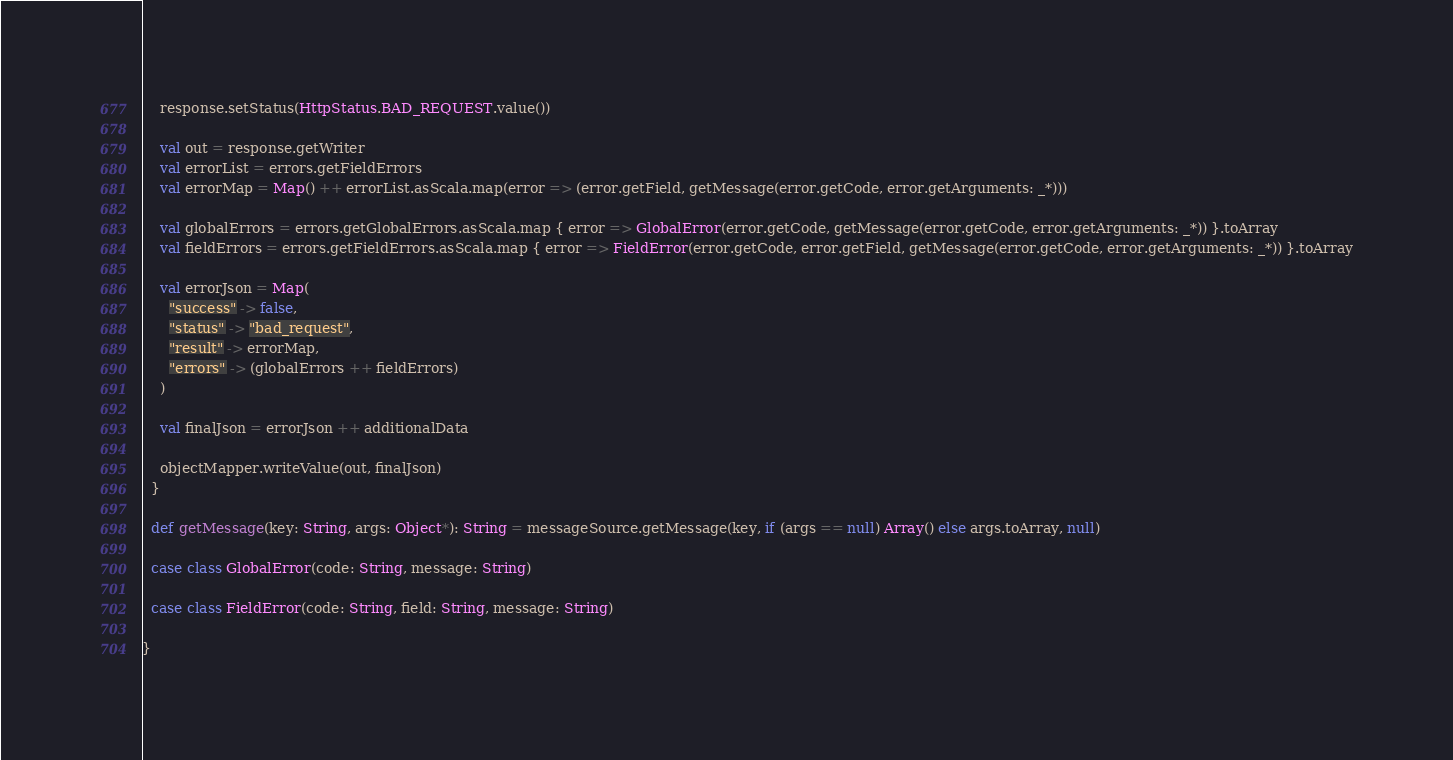<code> <loc_0><loc_0><loc_500><loc_500><_Scala_>    response.setStatus(HttpStatus.BAD_REQUEST.value())

    val out = response.getWriter
    val errorList = errors.getFieldErrors
    val errorMap = Map() ++ errorList.asScala.map(error => (error.getField, getMessage(error.getCode, error.getArguments: _*)))

    val globalErrors = errors.getGlobalErrors.asScala.map { error => GlobalError(error.getCode, getMessage(error.getCode, error.getArguments: _*)) }.toArray
    val fieldErrors = errors.getFieldErrors.asScala.map { error => FieldError(error.getCode, error.getField, getMessage(error.getCode, error.getArguments: _*)) }.toArray

    val errorJson = Map(
      "success" -> false,
      "status" -> "bad_request",
      "result" -> errorMap,
      "errors" -> (globalErrors ++ fieldErrors)
    )

    val finalJson = errorJson ++ additionalData

    objectMapper.writeValue(out, finalJson)
  }

  def getMessage(key: String, args: Object*): String = messageSource.getMessage(key, if (args == null) Array() else args.toArray, null)

  case class GlobalError(code: String, message: String)

  case class FieldError(code: String, field: String, message: String)

}
</code> 